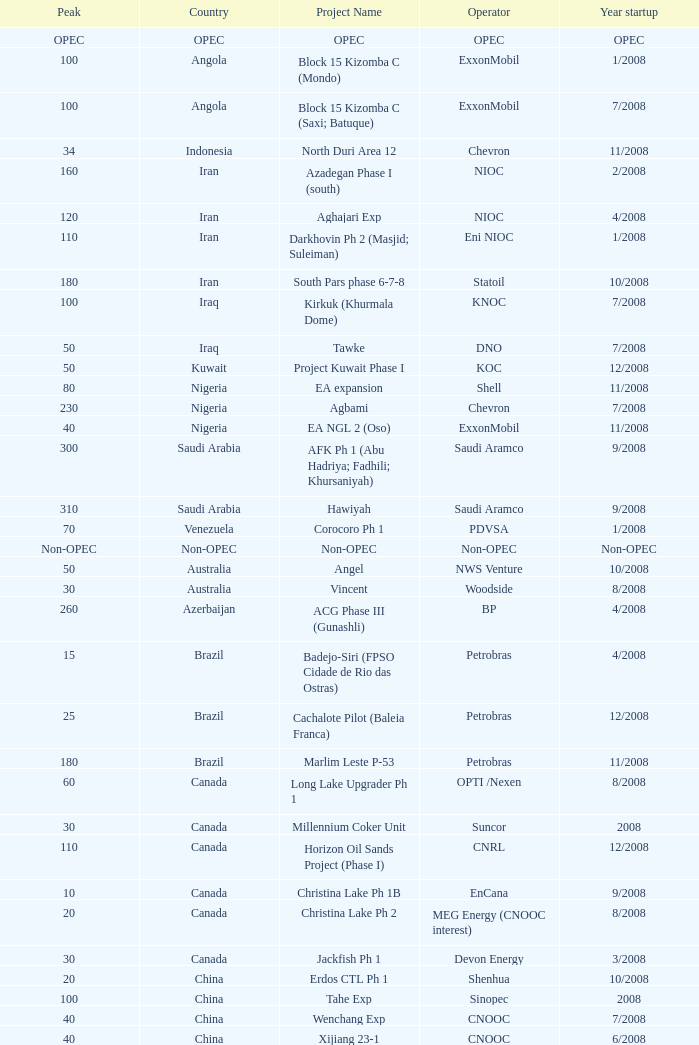What is the Operator with a Peak that is 55? PEMEX. 